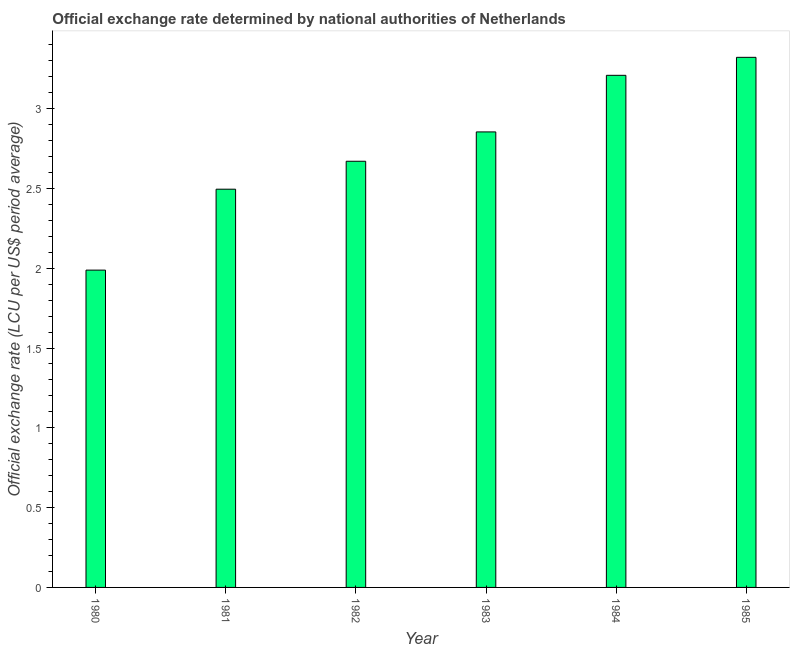Does the graph contain any zero values?
Provide a succinct answer. No. What is the title of the graph?
Your answer should be compact. Official exchange rate determined by national authorities of Netherlands. What is the label or title of the X-axis?
Your answer should be very brief. Year. What is the label or title of the Y-axis?
Your response must be concise. Official exchange rate (LCU per US$ period average). What is the official exchange rate in 1985?
Your response must be concise. 3.32. Across all years, what is the maximum official exchange rate?
Your answer should be compact. 3.32. Across all years, what is the minimum official exchange rate?
Offer a terse response. 1.99. In which year was the official exchange rate minimum?
Ensure brevity in your answer.  1980. What is the sum of the official exchange rate?
Your answer should be compact. 16.54. What is the difference between the official exchange rate in 1981 and 1983?
Provide a succinct answer. -0.36. What is the average official exchange rate per year?
Your answer should be very brief. 2.76. What is the median official exchange rate?
Offer a very short reply. 2.76. In how many years, is the official exchange rate greater than 2.6 ?
Your answer should be very brief. 4. What is the ratio of the official exchange rate in 1980 to that in 1985?
Offer a terse response. 0.6. What is the difference between the highest and the second highest official exchange rate?
Keep it short and to the point. 0.11. Is the sum of the official exchange rate in 1982 and 1985 greater than the maximum official exchange rate across all years?
Keep it short and to the point. Yes. What is the difference between the highest and the lowest official exchange rate?
Provide a short and direct response. 1.33. Are all the bars in the graph horizontal?
Make the answer very short. No. Are the values on the major ticks of Y-axis written in scientific E-notation?
Keep it short and to the point. No. What is the Official exchange rate (LCU per US$ period average) in 1980?
Your answer should be very brief. 1.99. What is the Official exchange rate (LCU per US$ period average) in 1981?
Your answer should be compact. 2.5. What is the Official exchange rate (LCU per US$ period average) of 1982?
Offer a terse response. 2.67. What is the Official exchange rate (LCU per US$ period average) of 1983?
Provide a succinct answer. 2.85. What is the Official exchange rate (LCU per US$ period average) in 1984?
Offer a very short reply. 3.21. What is the Official exchange rate (LCU per US$ period average) in 1985?
Your response must be concise. 3.32. What is the difference between the Official exchange rate (LCU per US$ period average) in 1980 and 1981?
Keep it short and to the point. -0.51. What is the difference between the Official exchange rate (LCU per US$ period average) in 1980 and 1982?
Give a very brief answer. -0.68. What is the difference between the Official exchange rate (LCU per US$ period average) in 1980 and 1983?
Keep it short and to the point. -0.87. What is the difference between the Official exchange rate (LCU per US$ period average) in 1980 and 1984?
Give a very brief answer. -1.22. What is the difference between the Official exchange rate (LCU per US$ period average) in 1980 and 1985?
Your answer should be compact. -1.33. What is the difference between the Official exchange rate (LCU per US$ period average) in 1981 and 1982?
Make the answer very short. -0.18. What is the difference between the Official exchange rate (LCU per US$ period average) in 1981 and 1983?
Offer a very short reply. -0.36. What is the difference between the Official exchange rate (LCU per US$ period average) in 1981 and 1984?
Offer a very short reply. -0.71. What is the difference between the Official exchange rate (LCU per US$ period average) in 1981 and 1985?
Ensure brevity in your answer.  -0.83. What is the difference between the Official exchange rate (LCU per US$ period average) in 1982 and 1983?
Your answer should be very brief. -0.18. What is the difference between the Official exchange rate (LCU per US$ period average) in 1982 and 1984?
Give a very brief answer. -0.54. What is the difference between the Official exchange rate (LCU per US$ period average) in 1982 and 1985?
Make the answer very short. -0.65. What is the difference between the Official exchange rate (LCU per US$ period average) in 1983 and 1984?
Your answer should be compact. -0.35. What is the difference between the Official exchange rate (LCU per US$ period average) in 1983 and 1985?
Your answer should be compact. -0.47. What is the difference between the Official exchange rate (LCU per US$ period average) in 1984 and 1985?
Provide a short and direct response. -0.11. What is the ratio of the Official exchange rate (LCU per US$ period average) in 1980 to that in 1981?
Your answer should be very brief. 0.8. What is the ratio of the Official exchange rate (LCU per US$ period average) in 1980 to that in 1982?
Your answer should be compact. 0.74. What is the ratio of the Official exchange rate (LCU per US$ period average) in 1980 to that in 1983?
Give a very brief answer. 0.7. What is the ratio of the Official exchange rate (LCU per US$ period average) in 1980 to that in 1984?
Make the answer very short. 0.62. What is the ratio of the Official exchange rate (LCU per US$ period average) in 1980 to that in 1985?
Give a very brief answer. 0.6. What is the ratio of the Official exchange rate (LCU per US$ period average) in 1981 to that in 1982?
Keep it short and to the point. 0.93. What is the ratio of the Official exchange rate (LCU per US$ period average) in 1981 to that in 1983?
Offer a very short reply. 0.87. What is the ratio of the Official exchange rate (LCU per US$ period average) in 1981 to that in 1984?
Offer a terse response. 0.78. What is the ratio of the Official exchange rate (LCU per US$ period average) in 1981 to that in 1985?
Make the answer very short. 0.75. What is the ratio of the Official exchange rate (LCU per US$ period average) in 1982 to that in 1983?
Provide a succinct answer. 0.94. What is the ratio of the Official exchange rate (LCU per US$ period average) in 1982 to that in 1984?
Your response must be concise. 0.83. What is the ratio of the Official exchange rate (LCU per US$ period average) in 1982 to that in 1985?
Your answer should be compact. 0.8. What is the ratio of the Official exchange rate (LCU per US$ period average) in 1983 to that in 1984?
Provide a short and direct response. 0.89. What is the ratio of the Official exchange rate (LCU per US$ period average) in 1983 to that in 1985?
Give a very brief answer. 0.86. What is the ratio of the Official exchange rate (LCU per US$ period average) in 1984 to that in 1985?
Your response must be concise. 0.97. 